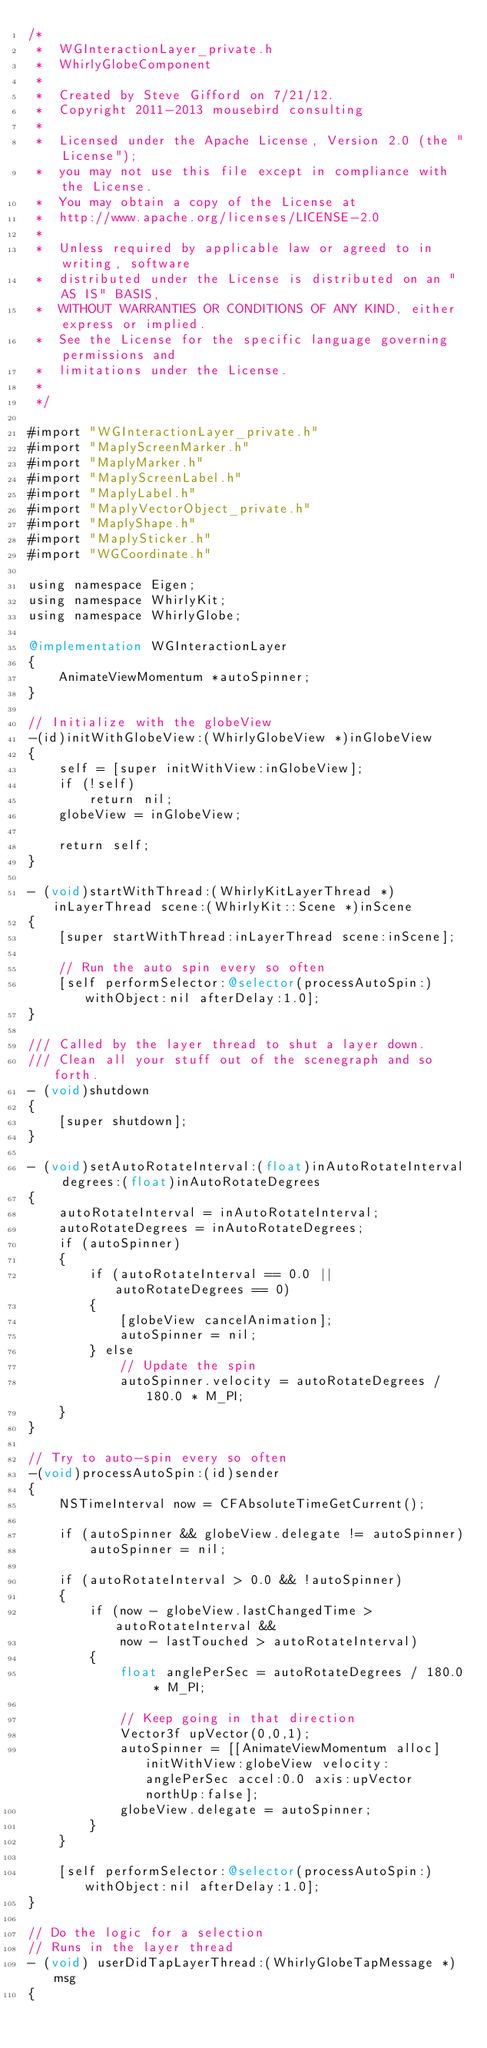Convert code to text. <code><loc_0><loc_0><loc_500><loc_500><_ObjectiveC_>/*
 *  WGInteractionLayer_private.h
 *  WhirlyGlobeComponent
 *
 *  Created by Steve Gifford on 7/21/12.
 *  Copyright 2011-2013 mousebird consulting
 *
 *  Licensed under the Apache License, Version 2.0 (the "License");
 *  you may not use this file except in compliance with the License.
 *  You may obtain a copy of the License at
 *  http://www.apache.org/licenses/LICENSE-2.0
 *
 *  Unless required by applicable law or agreed to in writing, software
 *  distributed under the License is distributed on an "AS IS" BASIS,
 *  WITHOUT WARRANTIES OR CONDITIONS OF ANY KIND, either express or implied.
 *  See the License for the specific language governing permissions and
 *  limitations under the License.
 *
 */

#import "WGInteractionLayer_private.h"
#import "MaplyScreenMarker.h"
#import "MaplyMarker.h"
#import "MaplyScreenLabel.h"
#import "MaplyLabel.h"
#import "MaplyVectorObject_private.h"
#import "MaplyShape.h"
#import "MaplySticker.h"
#import "WGCoordinate.h"

using namespace Eigen;
using namespace WhirlyKit;
using namespace WhirlyGlobe;

@implementation WGInteractionLayer
{
    AnimateViewMomentum *autoSpinner;
}

// Initialize with the globeView
-(id)initWithGlobeView:(WhirlyGlobeView *)inGlobeView
{
    self = [super initWithView:inGlobeView];
    if (!self)
        return nil;
    globeView = inGlobeView;
    
    return self;
}

- (void)startWithThread:(WhirlyKitLayerThread *)inLayerThread scene:(WhirlyKit::Scene *)inScene
{
    [super startWithThread:inLayerThread scene:inScene];
        
    // Run the auto spin every so often
    [self performSelector:@selector(processAutoSpin:) withObject:nil afterDelay:1.0];
}

/// Called by the layer thread to shut a layer down.
/// Clean all your stuff out of the scenegraph and so forth.
- (void)shutdown
{
    [super shutdown];
}

- (void)setAutoRotateInterval:(float)inAutoRotateInterval degrees:(float)inAutoRotateDegrees
{
    autoRotateInterval = inAutoRotateInterval;
    autoRotateDegrees = inAutoRotateDegrees;
    if (autoSpinner)
    {
        if (autoRotateInterval == 0.0 || autoRotateDegrees == 0)
        {
            [globeView cancelAnimation];
            autoSpinner = nil;
        } else
            // Update the spin
            autoSpinner.velocity = autoRotateDegrees / 180.0 * M_PI;
    }
}

// Try to auto-spin every so often
-(void)processAutoSpin:(id)sender
{
    NSTimeInterval now = CFAbsoluteTimeGetCurrent();
    
    if (autoSpinner && globeView.delegate != autoSpinner)
        autoSpinner = nil;
    
    if (autoRotateInterval > 0.0 && !autoSpinner)
    {
        if (now - globeView.lastChangedTime > autoRotateInterval &&
            now - lastTouched > autoRotateInterval)
        {
            float anglePerSec = autoRotateDegrees / 180.0 * M_PI;
            
            // Keep going in that direction
            Vector3f upVector(0,0,1);
            autoSpinner = [[AnimateViewMomentum alloc] initWithView:globeView velocity:anglePerSec accel:0.0 axis:upVector northUp:false];
            globeView.delegate = autoSpinner;
        }
    }
    
    [self performSelector:@selector(processAutoSpin:) withObject:nil afterDelay:1.0];
}

// Do the logic for a selection
// Runs in the layer thread
- (void) userDidTapLayerThread:(WhirlyGlobeTapMessage *)msg
{</code> 